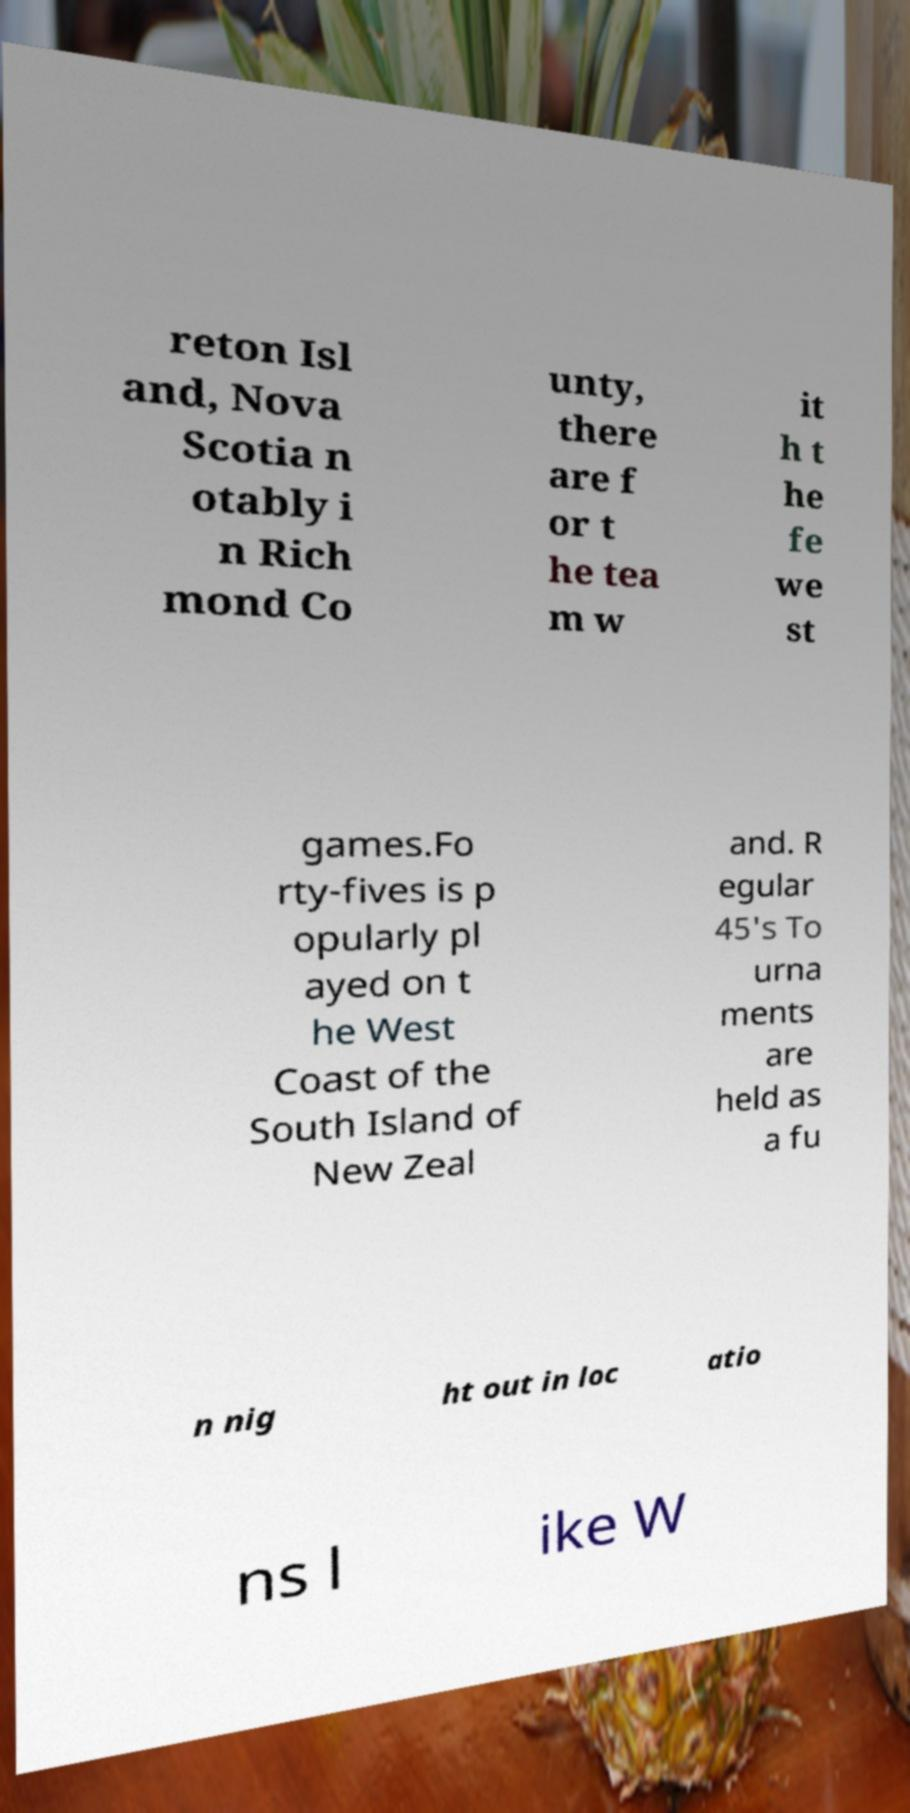Can you read and provide the text displayed in the image?This photo seems to have some interesting text. Can you extract and type it out for me? reton Isl and, Nova Scotia n otably i n Rich mond Co unty, there are f or t he tea m w it h t he fe we st games.Fo rty-fives is p opularly pl ayed on t he West Coast of the South Island of New Zeal and. R egular 45's To urna ments are held as a fu n nig ht out in loc atio ns l ike W 